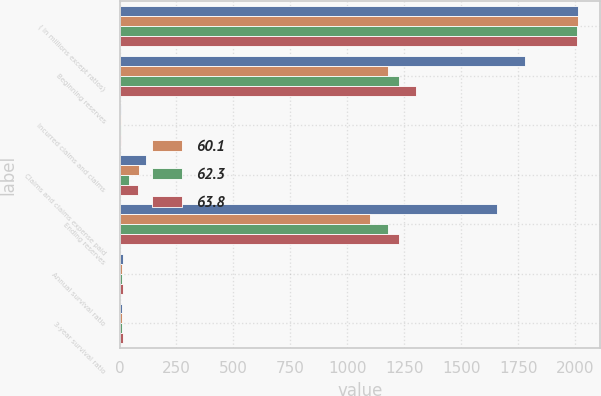Convert chart. <chart><loc_0><loc_0><loc_500><loc_500><stacked_bar_chart><ecel><fcel>( in millions except ratios)<fcel>Beginning reserves<fcel>Incurred claims and claims<fcel>Claims and claims expense paid<fcel>Ending reserves<fcel>Annual survival ratio<fcel>3-year survival ratio<nl><fcel>nan<fcel>2010<fcel>1780<fcel>7<fcel>118<fcel>1655<fcel>14<fcel>12.6<nl><fcel>60.1<fcel>2010<fcel>1180<fcel>5<fcel>85<fcel>1100<fcel>12.9<fcel>12.2<nl><fcel>62.3<fcel>2009<fcel>1228<fcel>8<fcel>40<fcel>1180<fcel>11.5<fcel>12.9<nl><fcel>63.8<fcel>2008<fcel>1302<fcel>8<fcel>82<fcel>1228<fcel>15.1<fcel>14.4<nl></chart> 